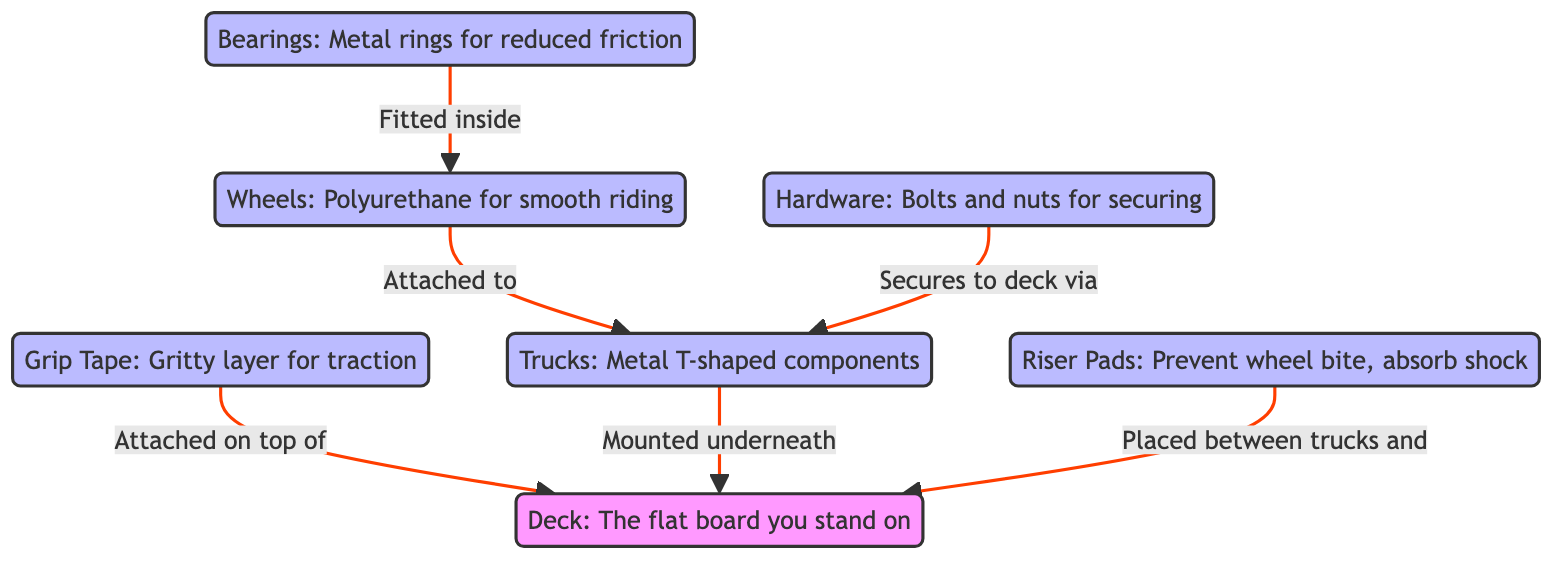What is the main surface you stand on while skateboarding? The diagram clearly indicates that the "Deck" is the flat board you stand on. By looking at the diagram, "deck" is directly labeled as such, making it easy to identify.
Answer: Deck What component is attached on top of the deck? The diagram shows an arrow from "Grip Tape" to "Deck", indicating that grip tape is attached on top of the deck for traction. This relationship is clearly depicted with a directional flow.
Answer: Grip Tape How many main components are listed in the diagram? By counting the main components in the diagram, we find that there are five labeled components: grip tape, trucks, wheels, bearings, and riser pads. This count includes all unique elements that are visually represented.
Answer: Five What is the function of riser pads? The diagram states that "Riser Pads" are used to prevent wheel bite and absorb shock. The purpose is explicitly described next to the identifier, which clarifies their functions within the overall skateboard system.
Answer: Prevent wheel bite, absorb shock Where are the trucks mounted? The diagram shows an arrow pointing from "Trucks" to "Deck", illustrating that trucks are mounted underneath the deck. This directional flow indicates the placement of the trucks in relation to the deck very clearly.
Answer: Underneath What do bearings reduce? The diagram specifies that "Bearings" are metal rings for reduced friction. We can see this information next to the labeled component. Hence, the reduction of friction is a key function of the bearings as depicted.
Answer: Friction What is the material used for the wheels? According to the diagram, the wheels are made of polyurethane. This material is listed explicitly next to the wheels in the label, which gives us the answer directly from visual information.
Answer: Polyurethane What secures the hardware to the deck? The diagram signifies that the "Hardware" secures to the deck via "Trucks". This relationship is illustrated with an arrow pointing from hardware towards the trucks, indicating how they are connected to the deck.
Answer: Trucks Which part is fitted inside the wheels? The diagram indicates "Bearings" are fitted inside the "Wheels." There is a directed edge from bearings to wheels that clarifies this relationship clearly.
Answer: Bearings 